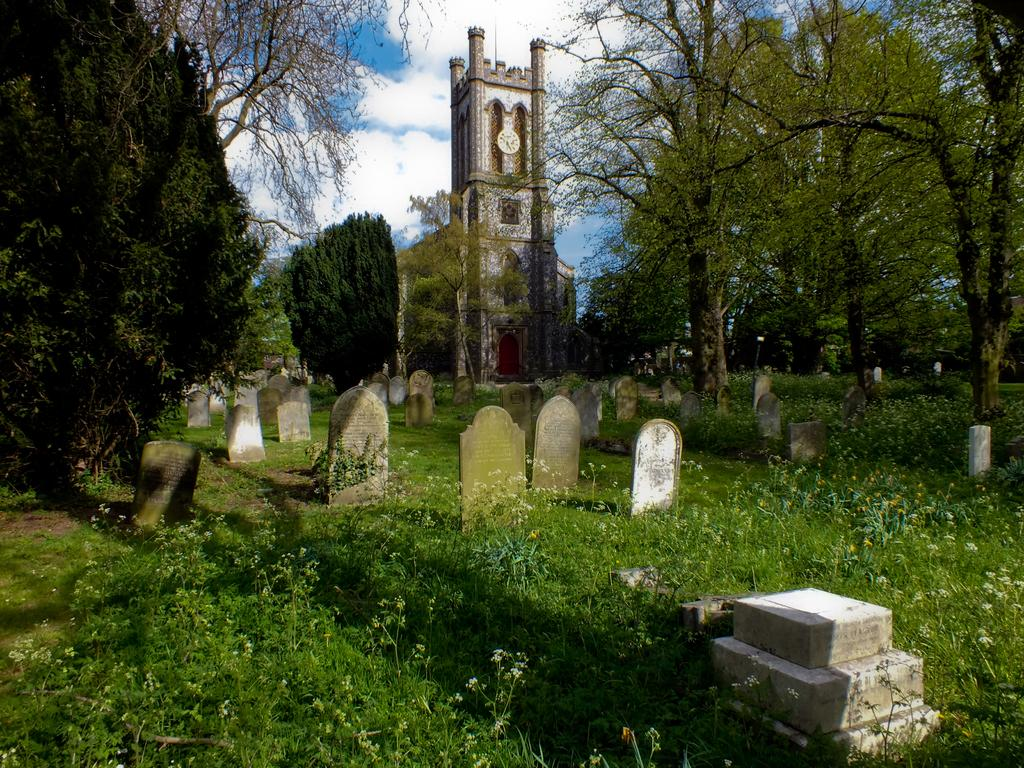What can be seen on the ground in the image? There are graves on the ground in the image. What type of vegetation is present in the image? There are plants and trees in the image. What type of structure is visible in the image? There is a building in the image. What is visible in the background of the image? The sky is visible in the background of the image. What can be seen in the sky in the image? Clouds are present in the sky. What type of oven is used to make the bubbles in the image? There is no oven or bubbles present in the image. What statement can be made about the presence of a bubble in the image? There is no bubble present in the image. 